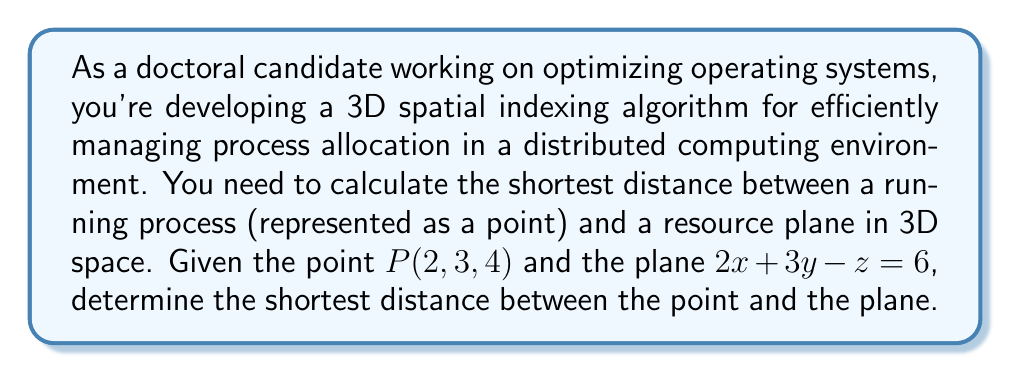What is the answer to this math problem? To find the shortest distance between a point and a plane in 3D space, we can use the following formula:

$$d = \frac{|Ax_0 + By_0 + Cz_0 + D|}{\sqrt{A^2 + B^2 + C^2}}$$

where $(x_0, y_0, z_0)$ is the given point, and $Ax + By + Cz + D = 0$ is the equation of the plane.

Step 1: Identify the components from the given information
- Point $P(2, 3, 4)$, so $x_0 = 2$, $y_0 = 3$, $z_0 = 4$
- Plane equation $2x + 3y - z = 6$, which we need to rewrite as $2x + 3y - z - 6 = 0$
  So, $A = 2$, $B = 3$, $C = -1$, and $D = -6$

Step 2: Substitute the values into the formula
$$d = \frac{|2(2) + 3(3) + (-1)(4) + (-6)|}{\sqrt{2^2 + 3^2 + (-1)^2}}$$

Step 3: Simplify the numerator
$$d = \frac{|4 + 9 - 4 - 6|}{\sqrt{4 + 9 + 1}}$$
$$d = \frac{|3|}{\sqrt{14}}$$

Step 4: Simplify the fraction
$$d = \frac{3}{\sqrt{14}}$$

To get a decimal approximation:
$$d \approx 0.8018$$

This result represents the shortest distance between the point $P(2, 3, 4)$ and the plane $2x + 3y - z = 6$ in 3D space.
Answer: The shortest distance between the point $P(2, 3, 4)$ and the plane $2x + 3y - z = 6$ is $\frac{3}{\sqrt{14}}$ or approximately $0.8018$ units. 